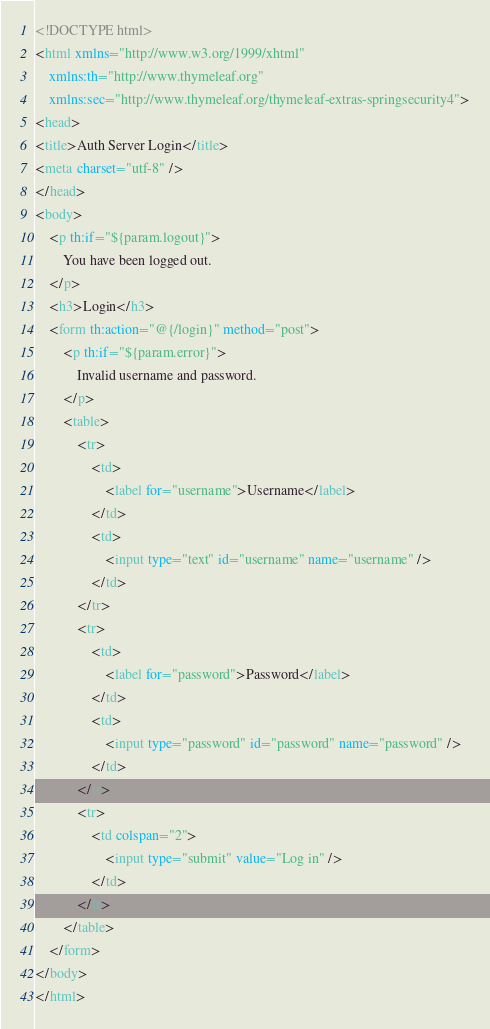Convert code to text. <code><loc_0><loc_0><loc_500><loc_500><_HTML_><!DOCTYPE html>
<html xmlns="http://www.w3.org/1999/xhtml"
	xmlns:th="http://www.thymeleaf.org"
	xmlns:sec="http://www.thymeleaf.org/thymeleaf-extras-springsecurity4">
<head>
<title>Auth Server Login</title>
<meta charset="utf-8" />
</head>
<body>
	<p th:if="${param.logout}">
		You have been logged out.
	</p>
	<h3>Login</h3>
	<form th:action="@{/login}" method="post">
		<p th:if="${param.error}">
			Invalid username and password.
		</p>
		<table>
			<tr>
				<td>
					<label for="username">Username</label>
				</td>
				<td>
					<input type="text" id="username" name="username" />
				</td>
			</tr>
			<tr>
				<td>
					<label for="password">Password</label>
				</td>
				<td>
					<input type="password" id="password" name="password" />
				</td>
			</tr>
			<tr>
				<td colspan="2">
					<input type="submit" value="Log in" />
				</td>
			</tr>
		</table>
	</form>
</body>
</html></code> 